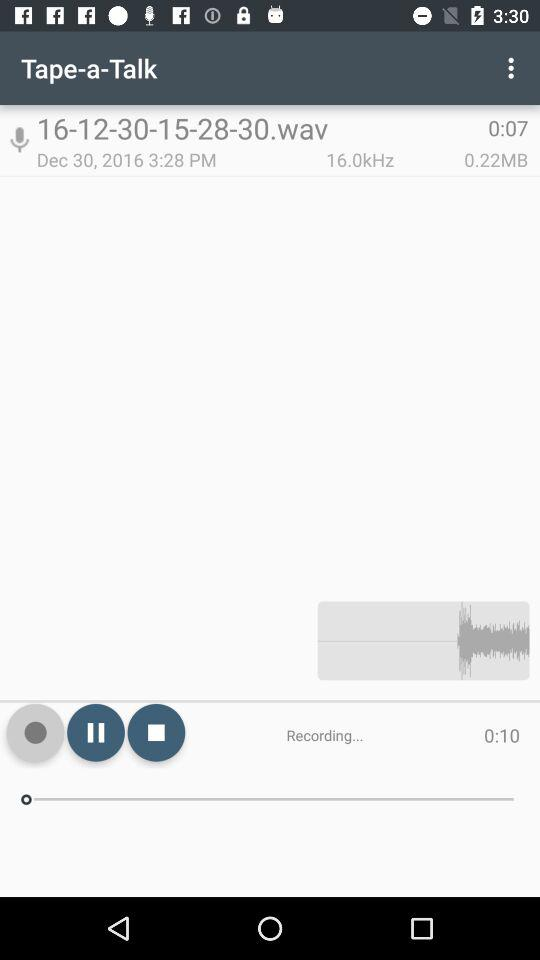What is the duration of the recording? The duration of the recording is 0:07. 